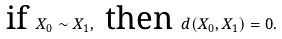<formula> <loc_0><loc_0><loc_500><loc_500>\text { if } X _ { 0 } \sim X _ { 1 } , \text { then } d ( X _ { 0 } , X _ { 1 } ) = 0 .</formula> 